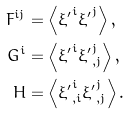<formula> <loc_0><loc_0><loc_500><loc_500>F ^ { i j } & = \left \langle { \xi ^ { \prime } } ^ { i } { \xi ^ { \prime } } ^ { j } \right \rangle , \\ G ^ { i } & = \left \langle { \xi ^ { \prime } } ^ { i } { \xi ^ { \prime } } ^ { j } _ { , j } \right \rangle , \\ H & = \left \langle { \xi ^ { \prime } } ^ { i } _ { , i } { \xi ^ { \prime } } ^ { j } _ { , j } \right \rangle .</formula> 